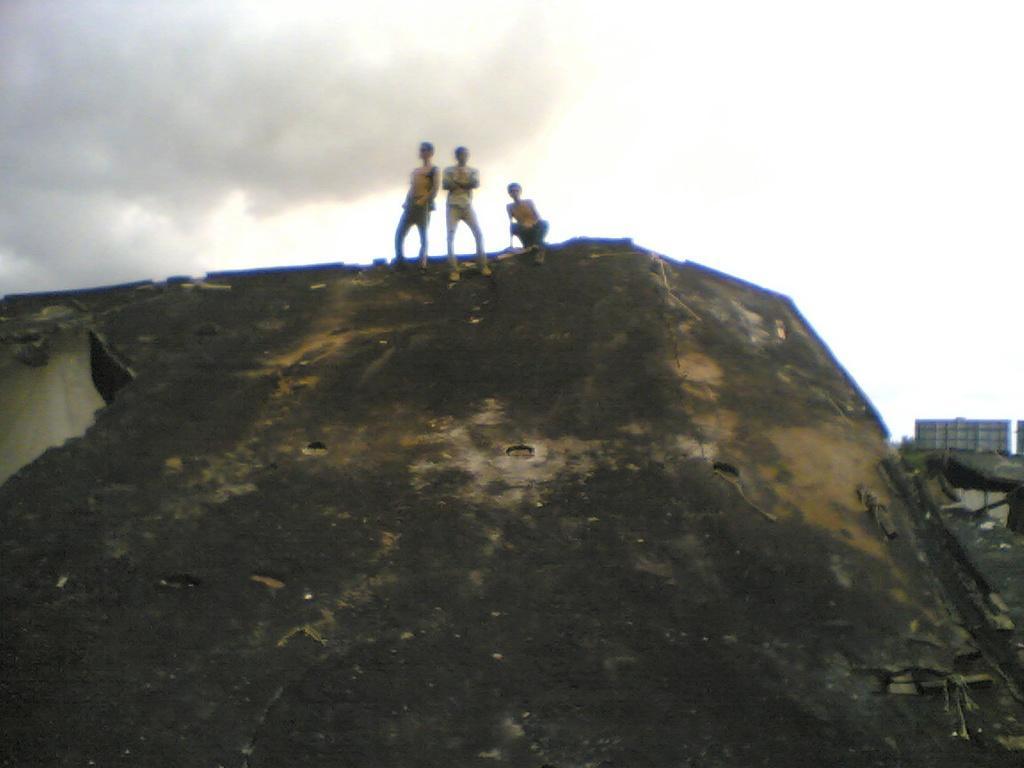Describe this image in one or two sentences. This image is taken outdoors. At the bottom of the image there is a hill. At the top of the image there is a sky with clouds. In the middle of the image three kids are standing on the hill. On the right side of the image there is a hill. 